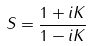Convert formula to latex. <formula><loc_0><loc_0><loc_500><loc_500>S = \frac { 1 + i K } { 1 - i K }</formula> 